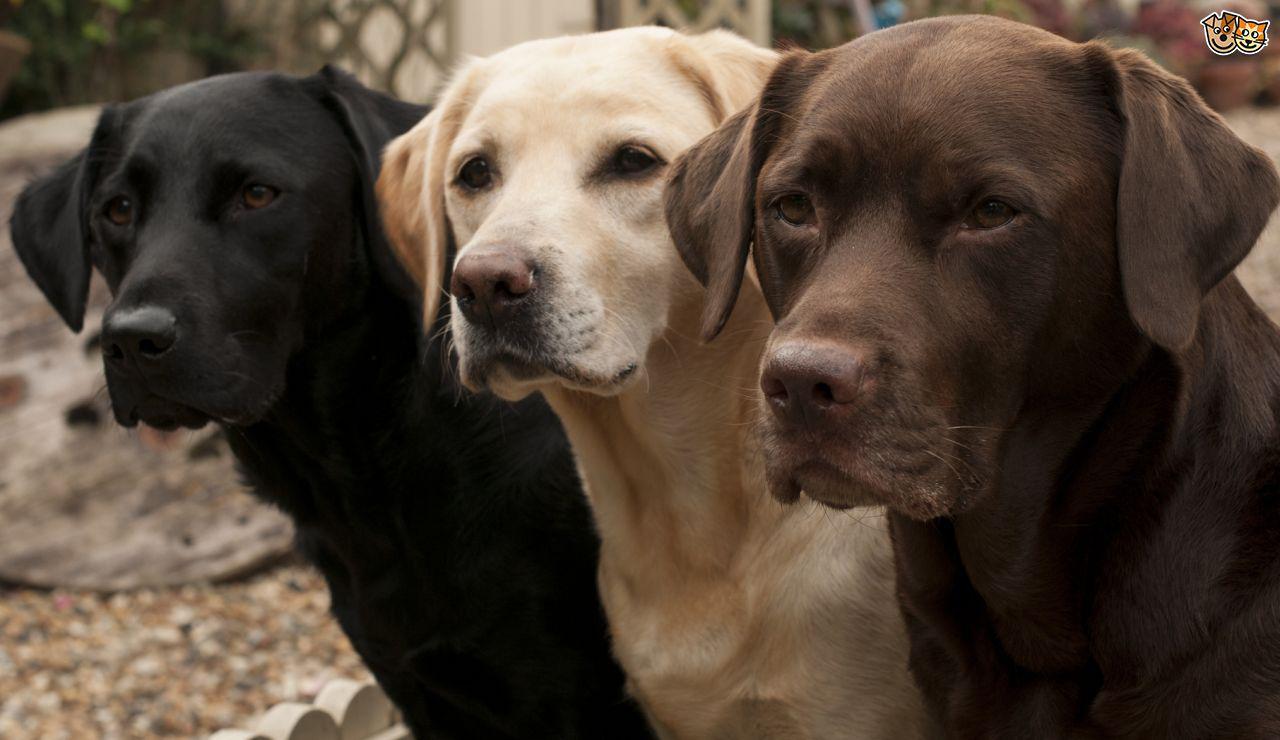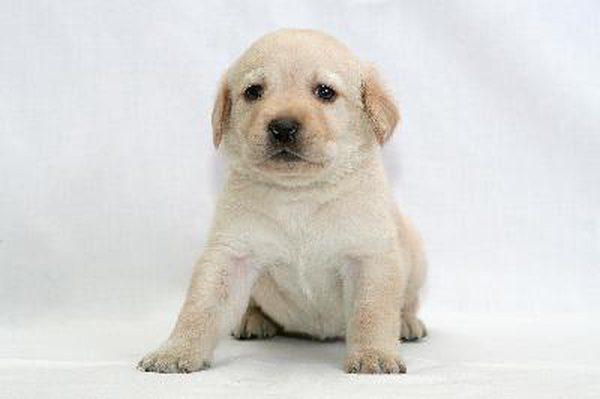The first image is the image on the left, the second image is the image on the right. Given the left and right images, does the statement "There are no less than four dogs" hold true? Answer yes or no. Yes. 